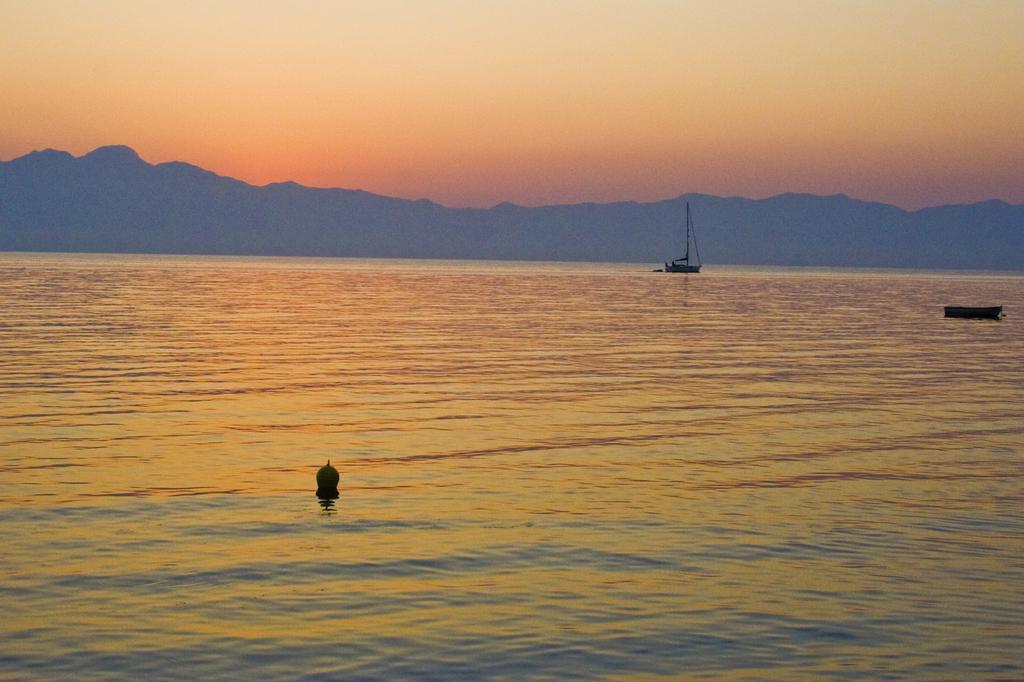Please provide a concise description of this image. It is a sea and in the middle of the sea there is a small boat and a ship,in the background there are few mountains. 